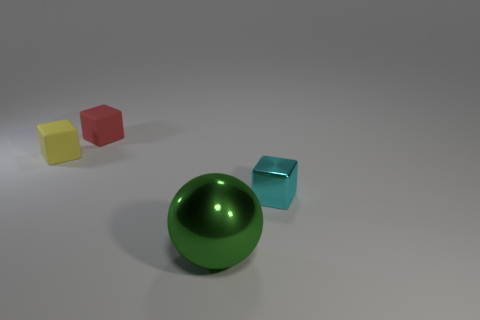Is there anything else that is the same size as the green sphere?
Your answer should be very brief. No. Is there anything else that is the same shape as the large green object?
Your answer should be compact. No. What number of shiny things are either red objects or big purple cylinders?
Offer a terse response. 0. What is the color of the tiny object that is on the right side of the tiny yellow matte thing and behind the small cyan shiny block?
Your answer should be very brief. Red. Does the block in front of the yellow block have the same size as the small red matte object?
Ensure brevity in your answer.  Yes. What number of objects are small objects to the left of the big green object or brown shiny balls?
Keep it short and to the point. 2. Are there any yellow rubber objects that have the same size as the red matte thing?
Your answer should be compact. Yes. There is a red thing that is the same size as the cyan metal cube; what material is it?
Make the answer very short. Rubber. What shape is the object that is both right of the tiny yellow object and behind the small cyan thing?
Offer a very short reply. Cube. The cube that is right of the big ball is what color?
Your answer should be very brief. Cyan. 